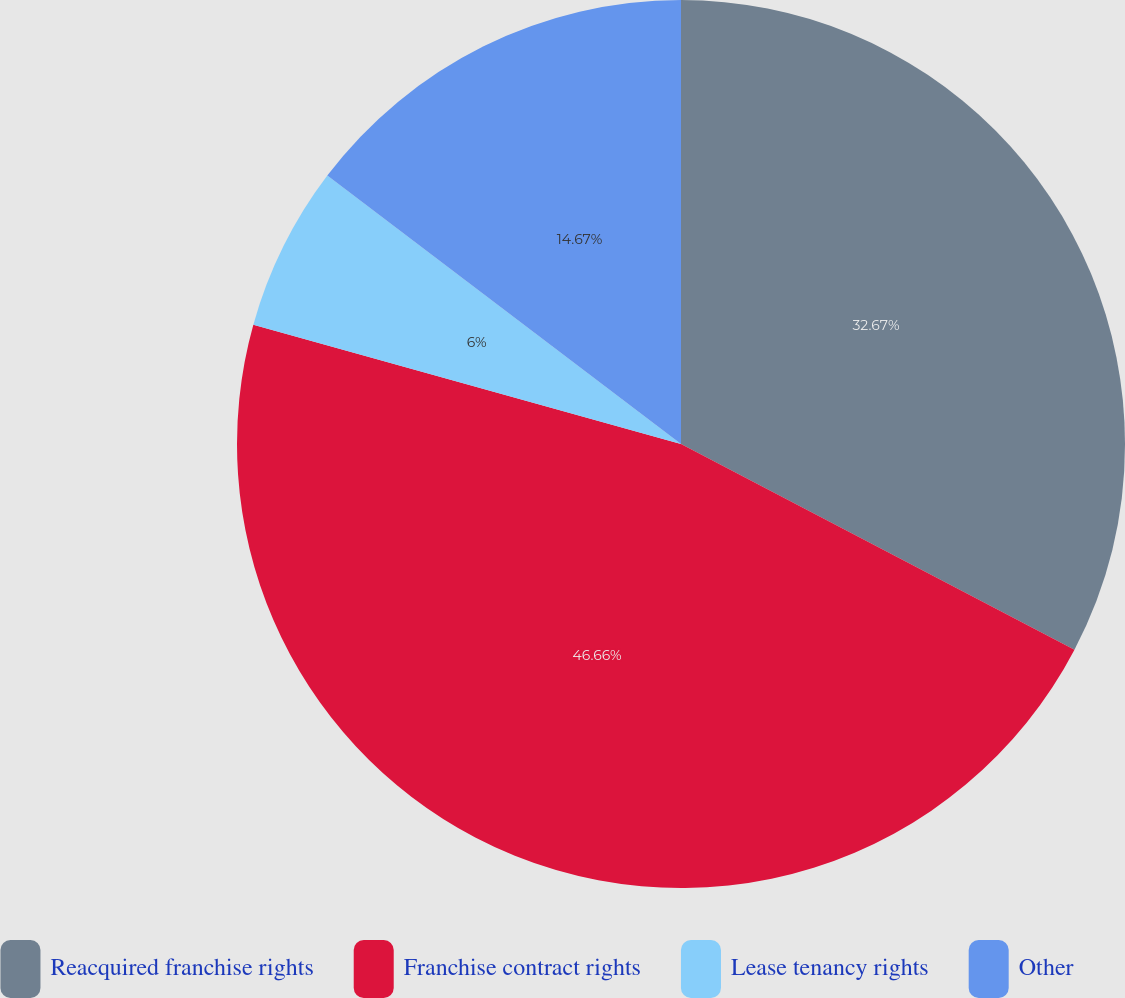Convert chart. <chart><loc_0><loc_0><loc_500><loc_500><pie_chart><fcel>Reacquired franchise rights<fcel>Franchise contract rights<fcel>Lease tenancy rights<fcel>Other<nl><fcel>32.67%<fcel>46.67%<fcel>6.0%<fcel>14.67%<nl></chart> 